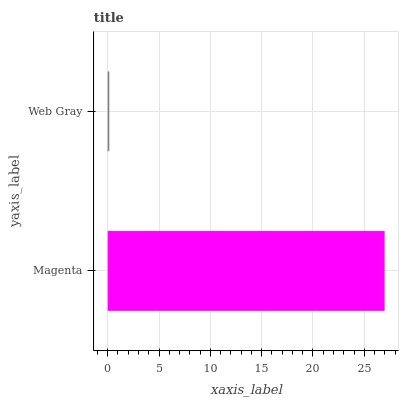Is Web Gray the minimum?
Answer yes or no. Yes. Is Magenta the maximum?
Answer yes or no. Yes. Is Web Gray the maximum?
Answer yes or no. No. Is Magenta greater than Web Gray?
Answer yes or no. Yes. Is Web Gray less than Magenta?
Answer yes or no. Yes. Is Web Gray greater than Magenta?
Answer yes or no. No. Is Magenta less than Web Gray?
Answer yes or no. No. Is Magenta the high median?
Answer yes or no. Yes. Is Web Gray the low median?
Answer yes or no. Yes. Is Web Gray the high median?
Answer yes or no. No. Is Magenta the low median?
Answer yes or no. No. 